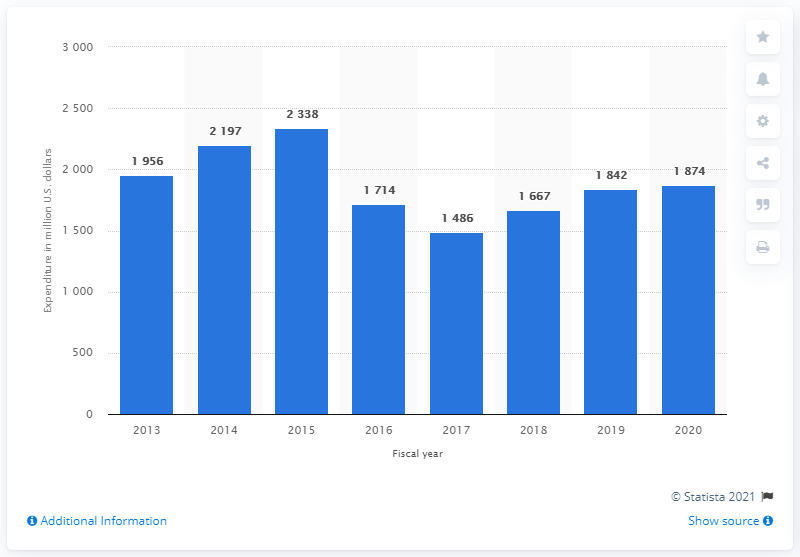Identify some key points in this picture. Hewlett Packard Enterprise (HPE) reported an R&D expenditure of 1874 in 2020. 